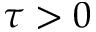<formula> <loc_0><loc_0><loc_500><loc_500>\tau > 0</formula> 